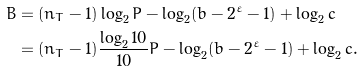<formula> <loc_0><loc_0><loc_500><loc_500>B & = ( n _ { T } - 1 ) \log _ { 2 } P - \log _ { 2 } ( b - 2 ^ { \varepsilon } - 1 ) + \log _ { 2 } c \\ & = ( n _ { T } - 1 ) \frac { \log _ { 2 } 1 0 } { 1 0 } P - \log _ { 2 } ( b - 2 ^ { \varepsilon } - 1 ) + \log _ { 2 } c .</formula> 